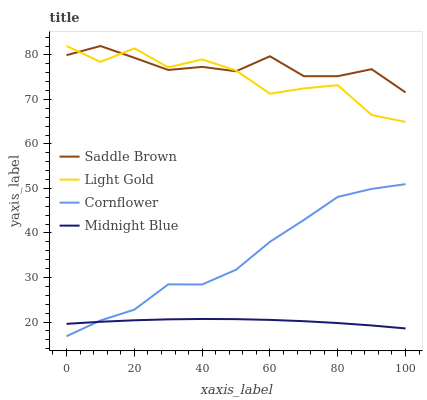Does Midnight Blue have the minimum area under the curve?
Answer yes or no. Yes. Does Saddle Brown have the maximum area under the curve?
Answer yes or no. Yes. Does Light Gold have the minimum area under the curve?
Answer yes or no. No. Does Light Gold have the maximum area under the curve?
Answer yes or no. No. Is Midnight Blue the smoothest?
Answer yes or no. Yes. Is Light Gold the roughest?
Answer yes or no. Yes. Is Saddle Brown the smoothest?
Answer yes or no. No. Is Saddle Brown the roughest?
Answer yes or no. No. Does Cornflower have the lowest value?
Answer yes or no. Yes. Does Light Gold have the lowest value?
Answer yes or no. No. Does Saddle Brown have the highest value?
Answer yes or no. Yes. Does Midnight Blue have the highest value?
Answer yes or no. No. Is Cornflower less than Light Gold?
Answer yes or no. Yes. Is Light Gold greater than Midnight Blue?
Answer yes or no. Yes. Does Light Gold intersect Saddle Brown?
Answer yes or no. Yes. Is Light Gold less than Saddle Brown?
Answer yes or no. No. Is Light Gold greater than Saddle Brown?
Answer yes or no. No. Does Cornflower intersect Light Gold?
Answer yes or no. No. 